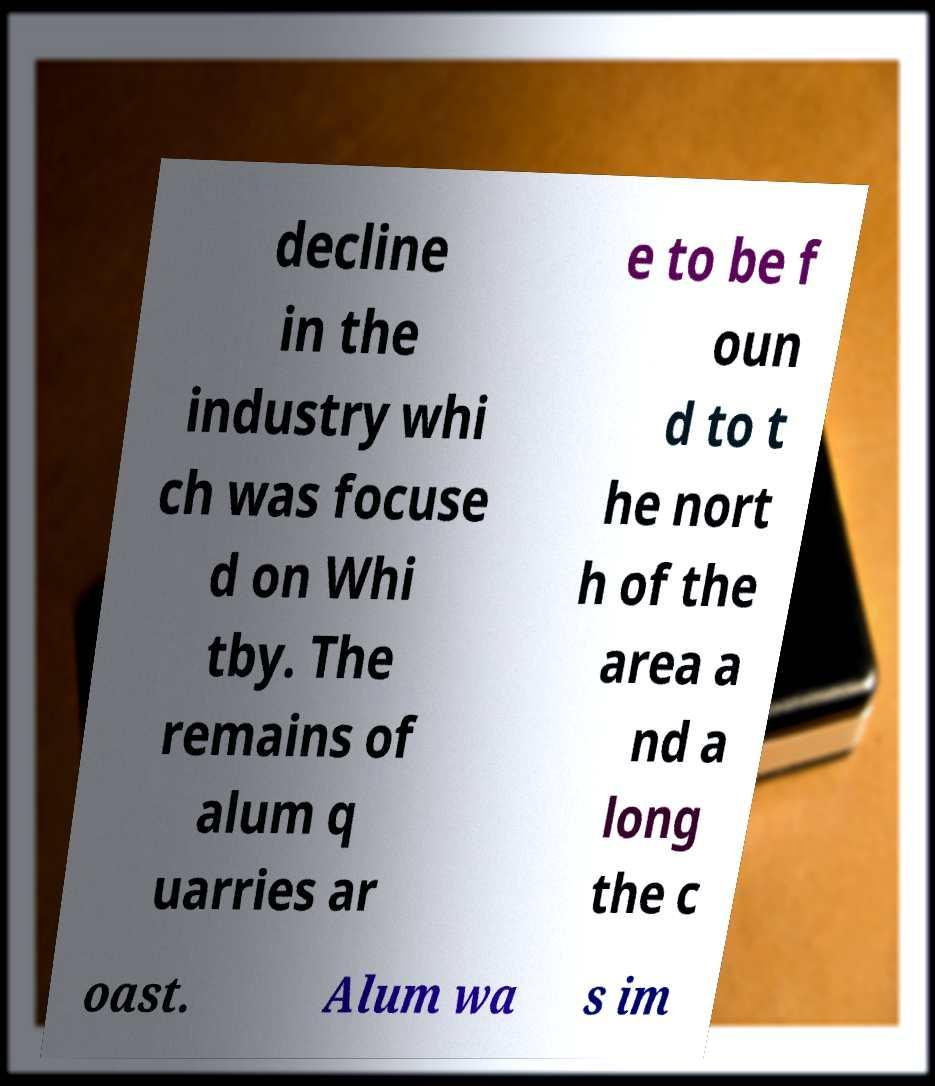Could you assist in decoding the text presented in this image and type it out clearly? decline in the industry whi ch was focuse d on Whi tby. The remains of alum q uarries ar e to be f oun d to t he nort h of the area a nd a long the c oast. Alum wa s im 